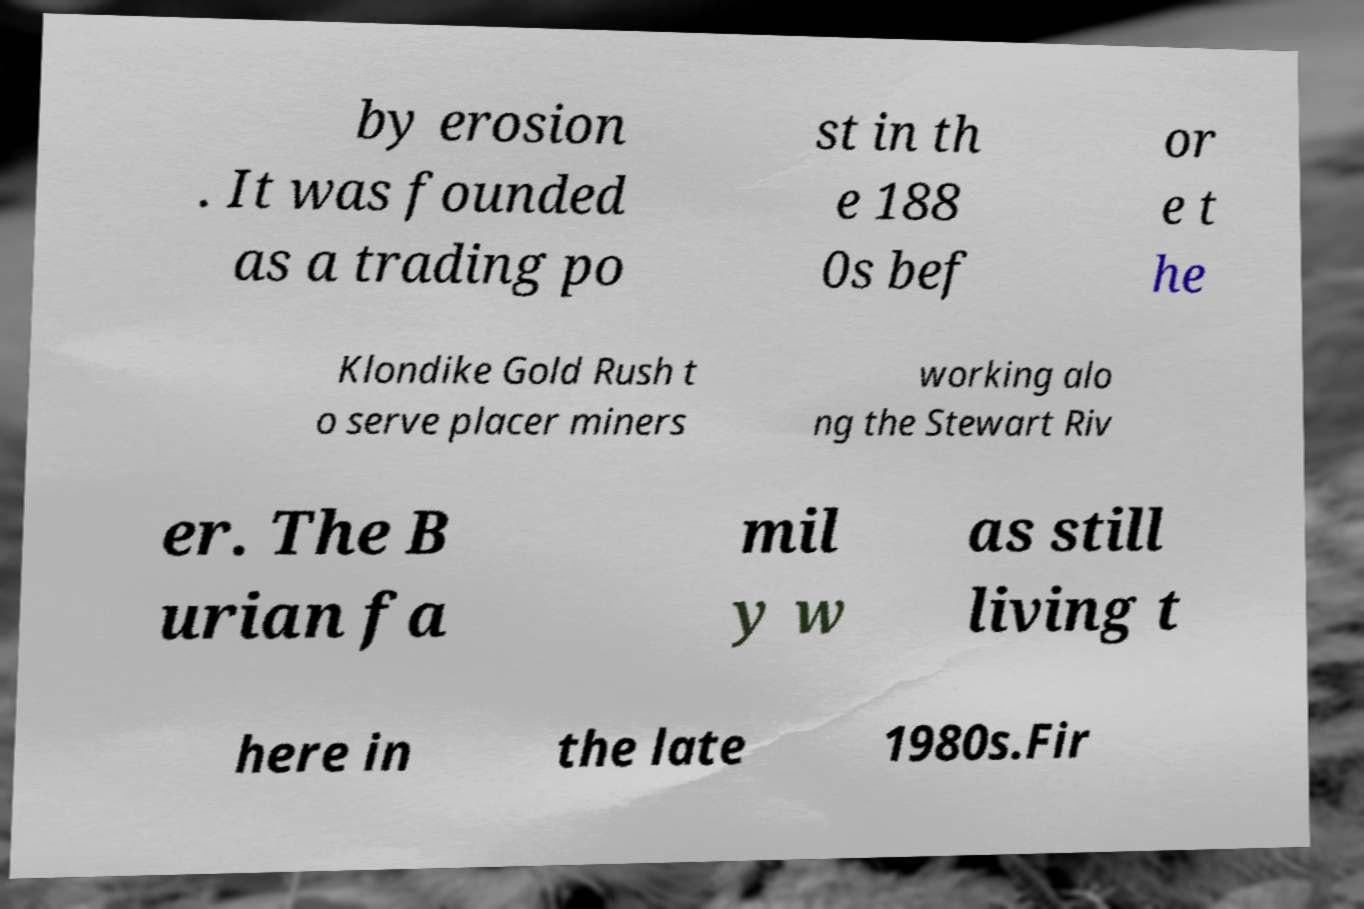Can you read and provide the text displayed in the image?This photo seems to have some interesting text. Can you extract and type it out for me? by erosion . It was founded as a trading po st in th e 188 0s bef or e t he Klondike Gold Rush t o serve placer miners working alo ng the Stewart Riv er. The B urian fa mil y w as still living t here in the late 1980s.Fir 